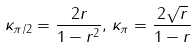<formula> <loc_0><loc_0><loc_500><loc_500>\kappa _ { \pi / 2 } = \frac { 2 r } { 1 - r ^ { 2 } } , \, \kappa _ { \pi } = \frac { 2 \sqrt { r } } { 1 - r }</formula> 